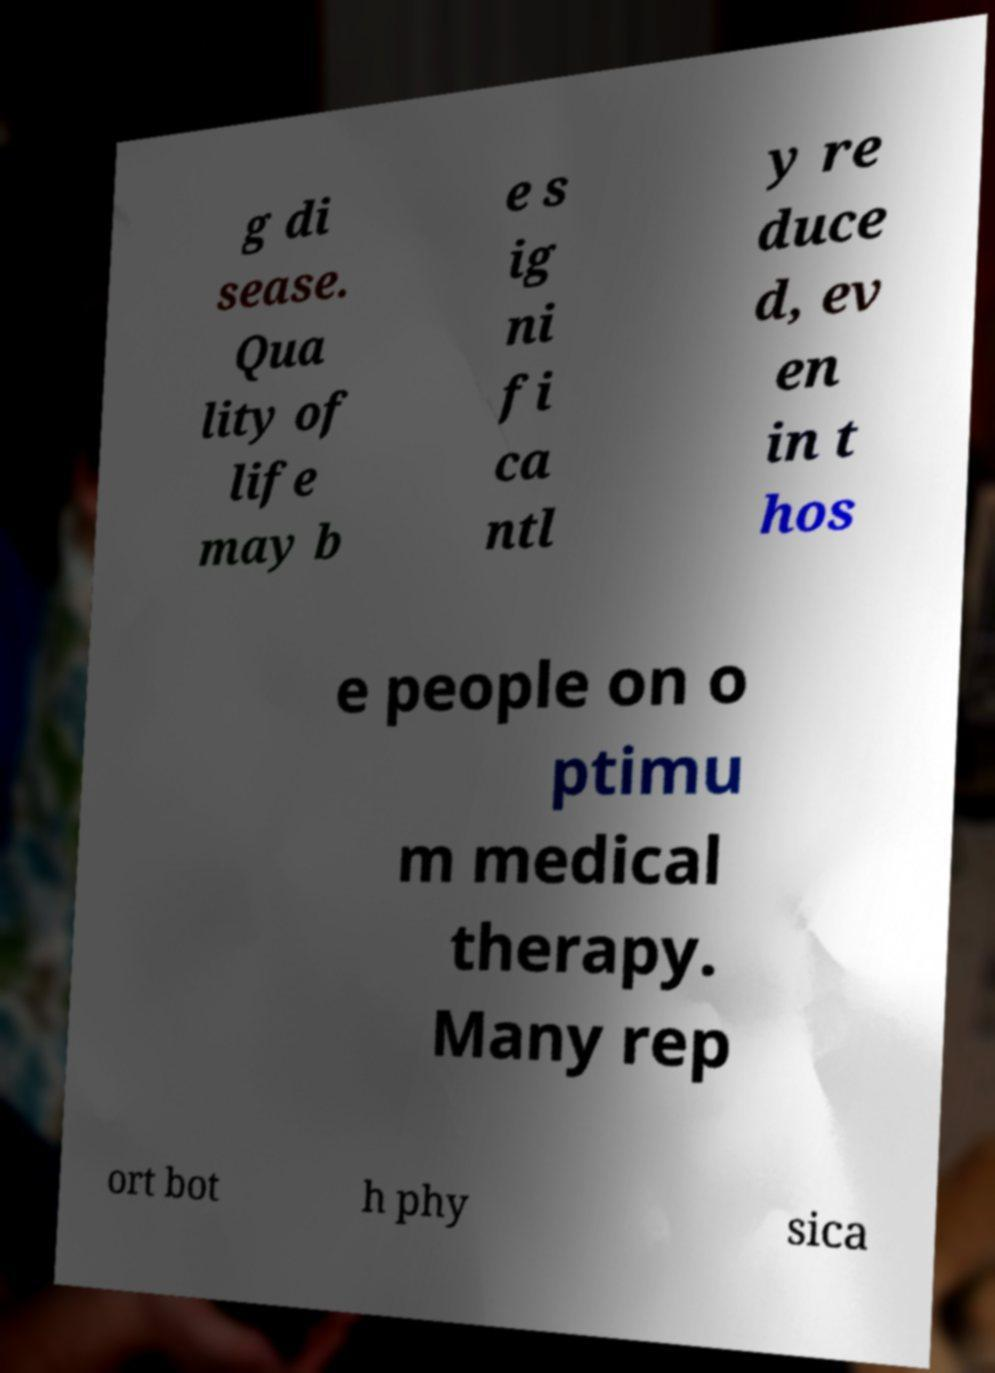I need the written content from this picture converted into text. Can you do that? g di sease. Qua lity of life may b e s ig ni fi ca ntl y re duce d, ev en in t hos e people on o ptimu m medical therapy. Many rep ort bot h phy sica 